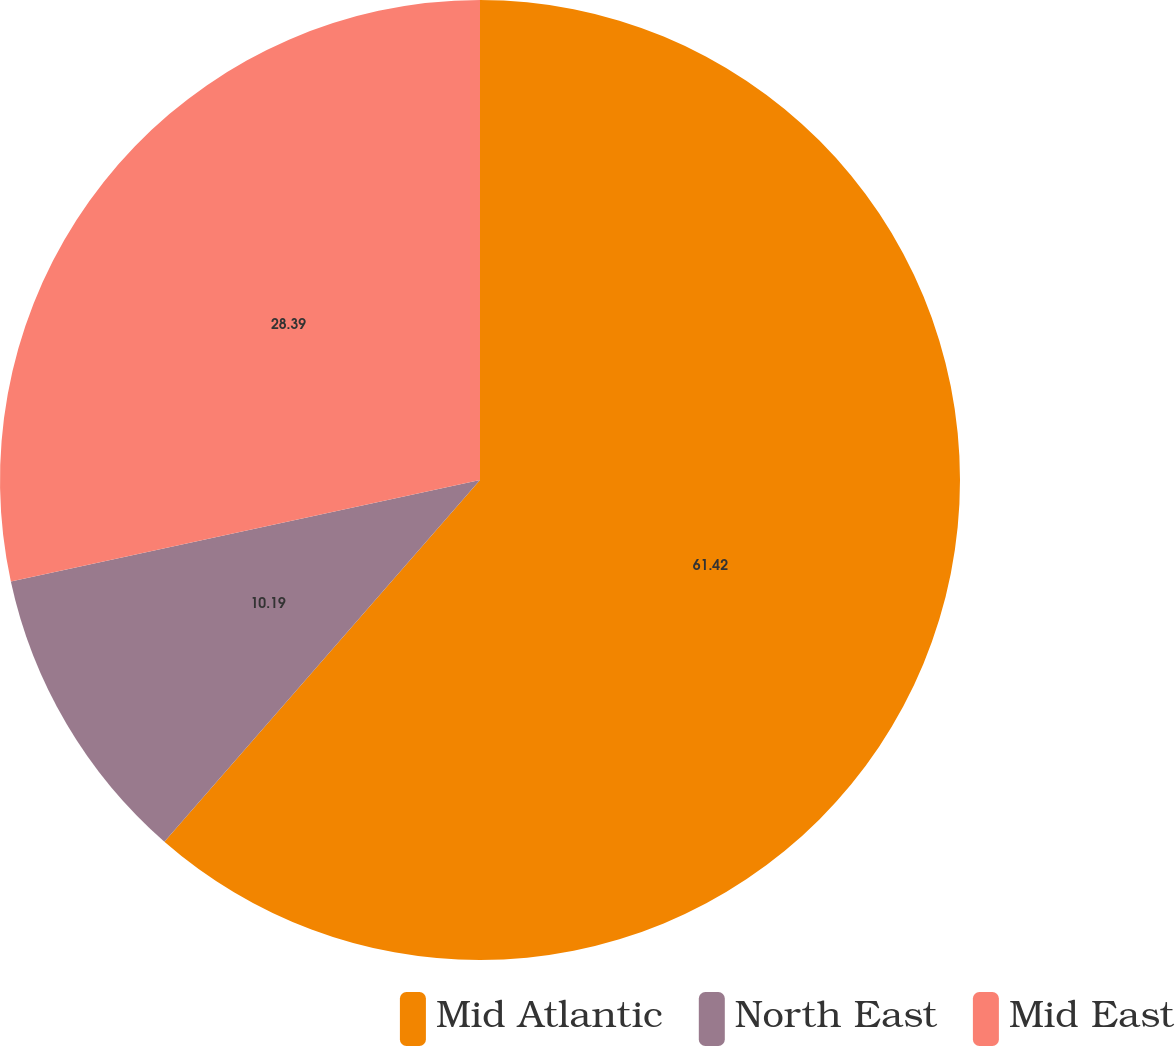Convert chart to OTSL. <chart><loc_0><loc_0><loc_500><loc_500><pie_chart><fcel>Mid Atlantic<fcel>North East<fcel>Mid East<nl><fcel>61.42%<fcel>10.19%<fcel>28.39%<nl></chart> 